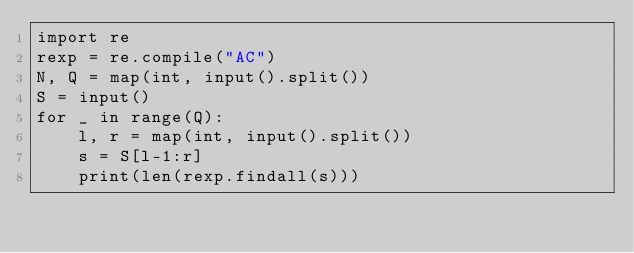<code> <loc_0><loc_0><loc_500><loc_500><_Python_>import re
rexp = re.compile("AC")
N, Q = map(int, input().split())
S = input()
for _ in range(Q):
    l, r = map(int, input().split())
    s = S[l-1:r]
    print(len(rexp.findall(s)))
</code> 